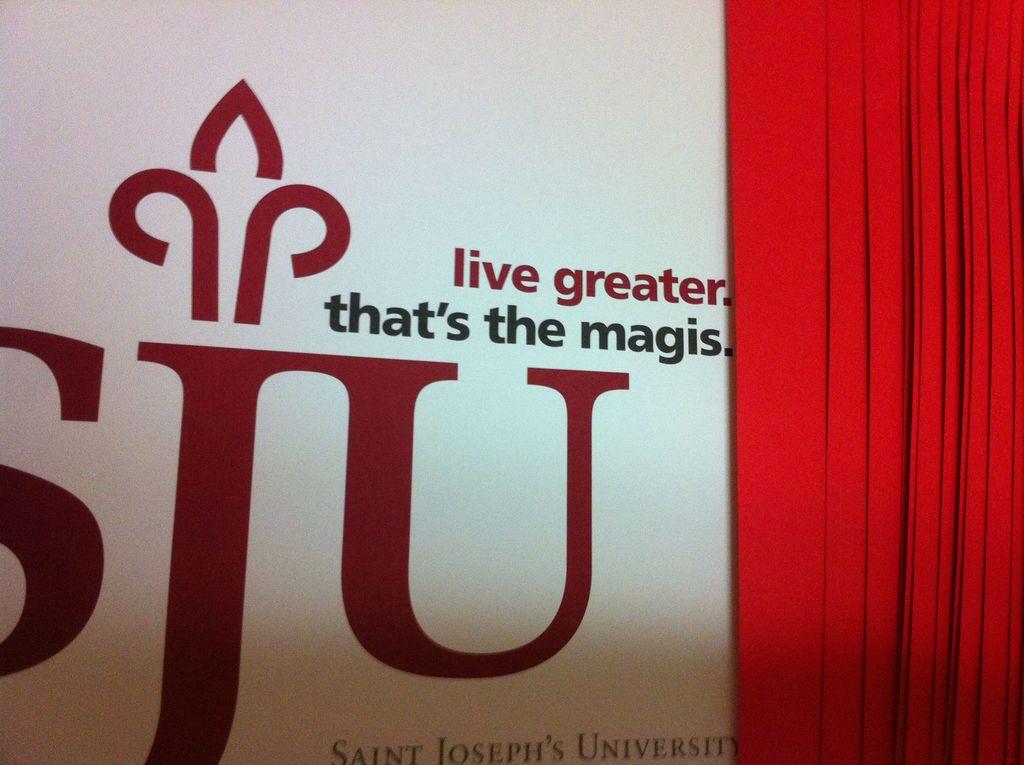What university is s.j.u.?
Your answer should be compact. Saint joseph's university. This is telling you to live what?
Make the answer very short. Greater. 